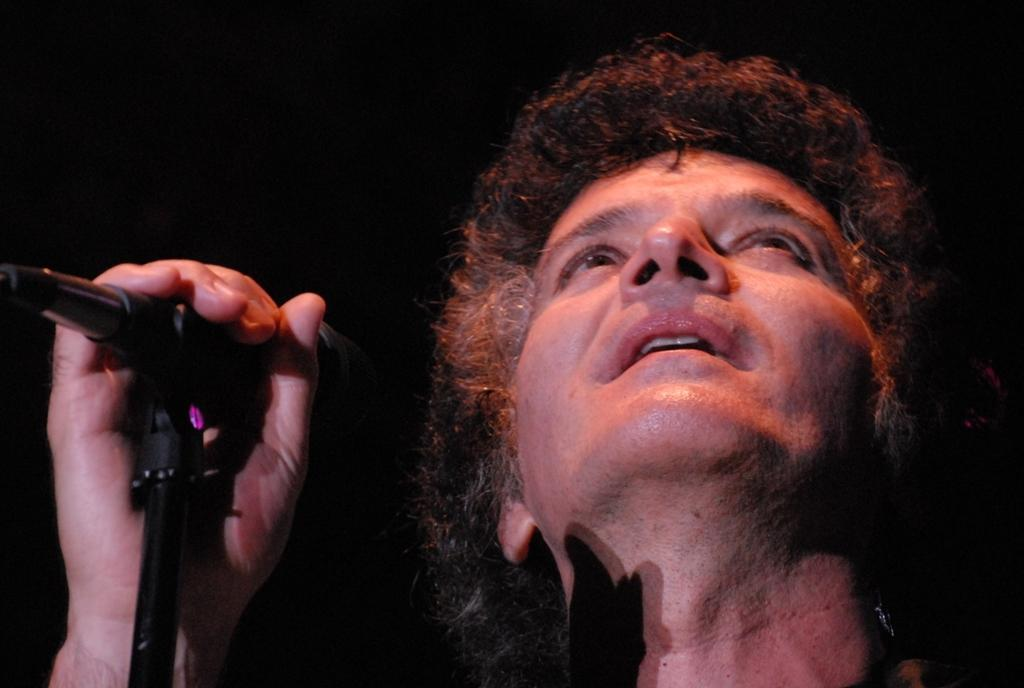What is the main subject of the image? There is a person in the image. What is the person holding in his hand? The person is holding a mic in his hand. What direction is the person looking in? The person is looking up. What theory is the person developing in the image? There is no indication of a theory being developed in the image; the person is simply holding a mic and looking up. 